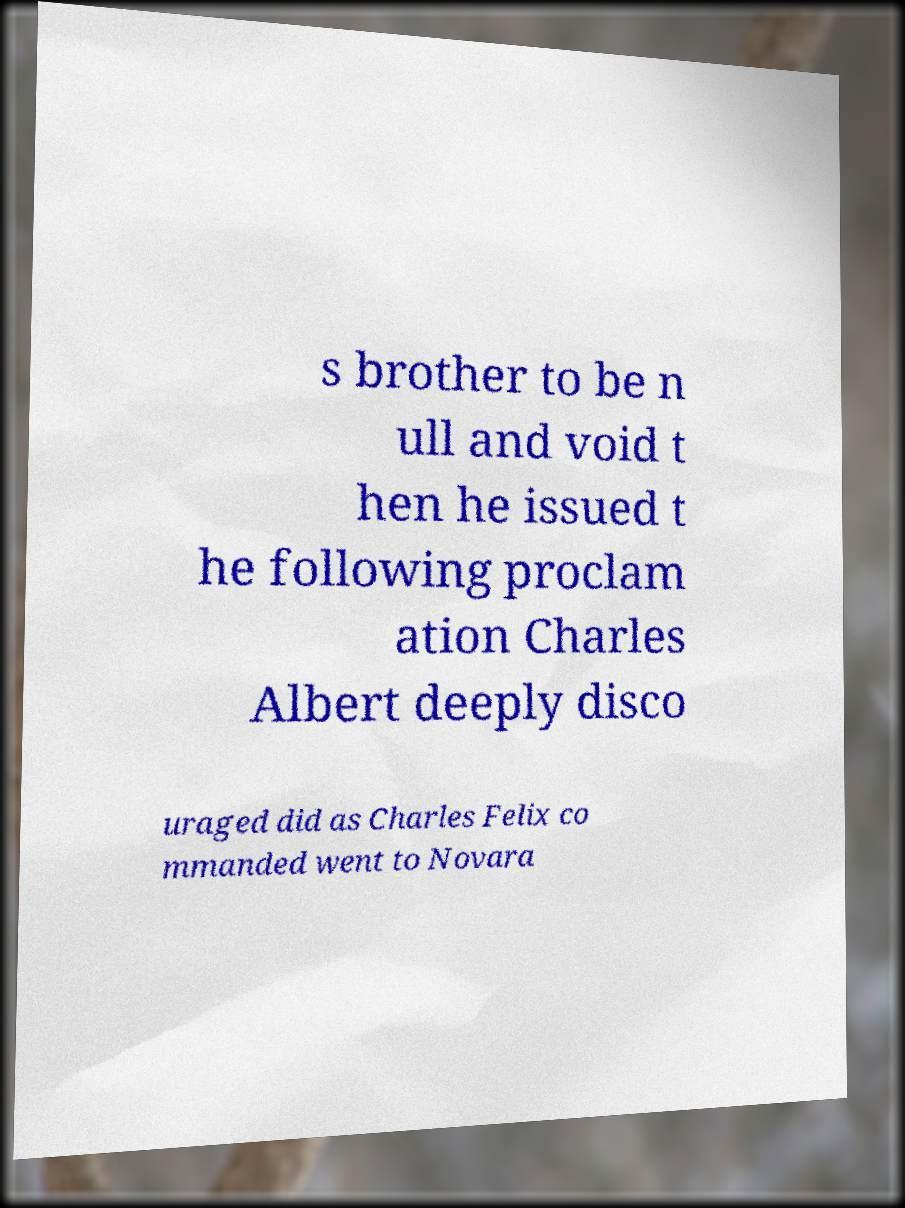Could you assist in decoding the text presented in this image and type it out clearly? s brother to be n ull and void t hen he issued t he following proclam ation Charles Albert deeply disco uraged did as Charles Felix co mmanded went to Novara 